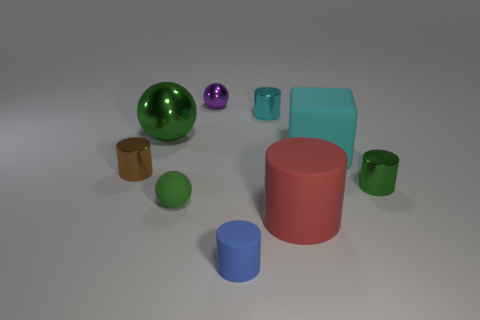Subtract all big green shiny balls. How many balls are left? 2 Subtract all blue cylinders. How many green balls are left? 2 Subtract 1 cylinders. How many cylinders are left? 4 Subtract all red cylinders. How many cylinders are left? 4 Add 1 tiny green metallic objects. How many objects exist? 10 Subtract all balls. How many objects are left? 6 Subtract all purple cylinders. Subtract all red cubes. How many cylinders are left? 5 Add 9 big green shiny objects. How many big green shiny objects are left? 10 Add 3 metallic cylinders. How many metallic cylinders exist? 6 Subtract 0 blue balls. How many objects are left? 9 